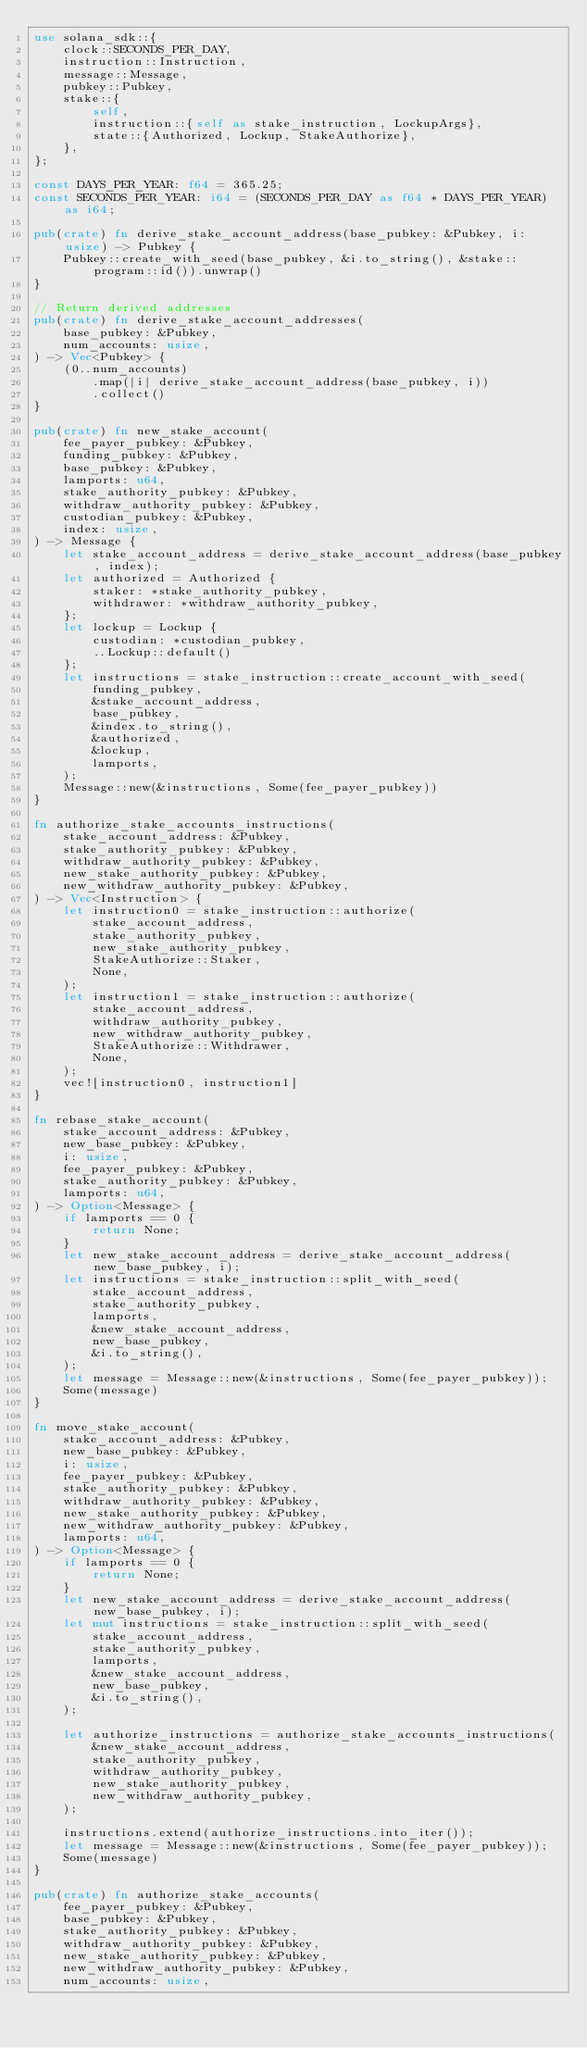Convert code to text. <code><loc_0><loc_0><loc_500><loc_500><_Rust_>use solana_sdk::{
    clock::SECONDS_PER_DAY,
    instruction::Instruction,
    message::Message,
    pubkey::Pubkey,
    stake::{
        self,
        instruction::{self as stake_instruction, LockupArgs},
        state::{Authorized, Lockup, StakeAuthorize},
    },
};

const DAYS_PER_YEAR: f64 = 365.25;
const SECONDS_PER_YEAR: i64 = (SECONDS_PER_DAY as f64 * DAYS_PER_YEAR) as i64;

pub(crate) fn derive_stake_account_address(base_pubkey: &Pubkey, i: usize) -> Pubkey {
    Pubkey::create_with_seed(base_pubkey, &i.to_string(), &stake::program::id()).unwrap()
}

// Return derived addresses
pub(crate) fn derive_stake_account_addresses(
    base_pubkey: &Pubkey,
    num_accounts: usize,
) -> Vec<Pubkey> {
    (0..num_accounts)
        .map(|i| derive_stake_account_address(base_pubkey, i))
        .collect()
}

pub(crate) fn new_stake_account(
    fee_payer_pubkey: &Pubkey,
    funding_pubkey: &Pubkey,
    base_pubkey: &Pubkey,
    lamports: u64,
    stake_authority_pubkey: &Pubkey,
    withdraw_authority_pubkey: &Pubkey,
    custodian_pubkey: &Pubkey,
    index: usize,
) -> Message {
    let stake_account_address = derive_stake_account_address(base_pubkey, index);
    let authorized = Authorized {
        staker: *stake_authority_pubkey,
        withdrawer: *withdraw_authority_pubkey,
    };
    let lockup = Lockup {
        custodian: *custodian_pubkey,
        ..Lockup::default()
    };
    let instructions = stake_instruction::create_account_with_seed(
        funding_pubkey,
        &stake_account_address,
        base_pubkey,
        &index.to_string(),
        &authorized,
        &lockup,
        lamports,
    );
    Message::new(&instructions, Some(fee_payer_pubkey))
}

fn authorize_stake_accounts_instructions(
    stake_account_address: &Pubkey,
    stake_authority_pubkey: &Pubkey,
    withdraw_authority_pubkey: &Pubkey,
    new_stake_authority_pubkey: &Pubkey,
    new_withdraw_authority_pubkey: &Pubkey,
) -> Vec<Instruction> {
    let instruction0 = stake_instruction::authorize(
        stake_account_address,
        stake_authority_pubkey,
        new_stake_authority_pubkey,
        StakeAuthorize::Staker,
        None,
    );
    let instruction1 = stake_instruction::authorize(
        stake_account_address,
        withdraw_authority_pubkey,
        new_withdraw_authority_pubkey,
        StakeAuthorize::Withdrawer,
        None,
    );
    vec![instruction0, instruction1]
}

fn rebase_stake_account(
    stake_account_address: &Pubkey,
    new_base_pubkey: &Pubkey,
    i: usize,
    fee_payer_pubkey: &Pubkey,
    stake_authority_pubkey: &Pubkey,
    lamports: u64,
) -> Option<Message> {
    if lamports == 0 {
        return None;
    }
    let new_stake_account_address = derive_stake_account_address(new_base_pubkey, i);
    let instructions = stake_instruction::split_with_seed(
        stake_account_address,
        stake_authority_pubkey,
        lamports,
        &new_stake_account_address,
        new_base_pubkey,
        &i.to_string(),
    );
    let message = Message::new(&instructions, Some(fee_payer_pubkey));
    Some(message)
}

fn move_stake_account(
    stake_account_address: &Pubkey,
    new_base_pubkey: &Pubkey,
    i: usize,
    fee_payer_pubkey: &Pubkey,
    stake_authority_pubkey: &Pubkey,
    withdraw_authority_pubkey: &Pubkey,
    new_stake_authority_pubkey: &Pubkey,
    new_withdraw_authority_pubkey: &Pubkey,
    lamports: u64,
) -> Option<Message> {
    if lamports == 0 {
        return None;
    }
    let new_stake_account_address = derive_stake_account_address(new_base_pubkey, i);
    let mut instructions = stake_instruction::split_with_seed(
        stake_account_address,
        stake_authority_pubkey,
        lamports,
        &new_stake_account_address,
        new_base_pubkey,
        &i.to_string(),
    );

    let authorize_instructions = authorize_stake_accounts_instructions(
        &new_stake_account_address,
        stake_authority_pubkey,
        withdraw_authority_pubkey,
        new_stake_authority_pubkey,
        new_withdraw_authority_pubkey,
    );

    instructions.extend(authorize_instructions.into_iter());
    let message = Message::new(&instructions, Some(fee_payer_pubkey));
    Some(message)
}

pub(crate) fn authorize_stake_accounts(
    fee_payer_pubkey: &Pubkey,
    base_pubkey: &Pubkey,
    stake_authority_pubkey: &Pubkey,
    withdraw_authority_pubkey: &Pubkey,
    new_stake_authority_pubkey: &Pubkey,
    new_withdraw_authority_pubkey: &Pubkey,
    num_accounts: usize,</code> 